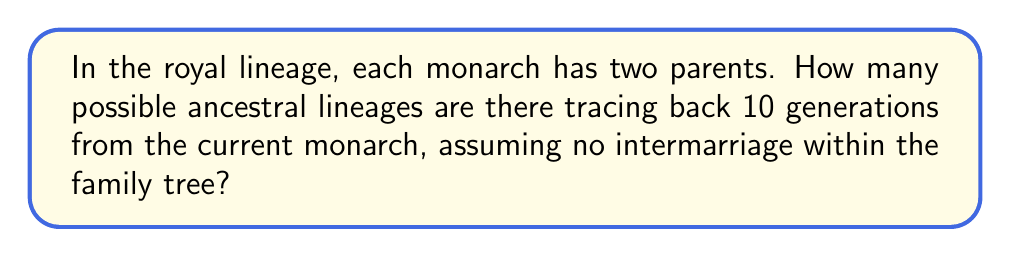Show me your answer to this math problem. Let's approach this step-by-step:

1) In each generation, the number of ancestors doubles:
   - 1st generation (parents): $2^1 = 2$
   - 2nd generation (grandparents): $2^2 = 4$
   - 3rd generation (great-grandparents): $2^3 = 8$
   And so on...

2) For the 10th generation, we would have $2^{10}$ ancestors.

3) However, the question asks for the number of lineages, not the number of ancestors. A lineage is a path from the current monarch to any one ancestor in the 10th generation.

4) Each lineage is a unique sequence of choices, where at each generation we choose either the maternal or paternal line.

5) Since we have 10 generations, and at each generation we make one of two choices, we can represent this as a sequence of 10 binary choices.

6) The number of such sequences is given by $2^{10}$, which is the same as the number of ancestors in the 10th generation.

7) Therefore, the number of possible ancestral lineages tracing back 10 generations is $2^{10} = 1024$.

This traditional approach to royal genealogy demonstrates the exponential growth of ancestral lines, a concept that might be both fascinating and potentially concerning to an elderly royal mindful of the complexities of succession and heritage.
Answer: $2^{10} = 1024$ lineages 